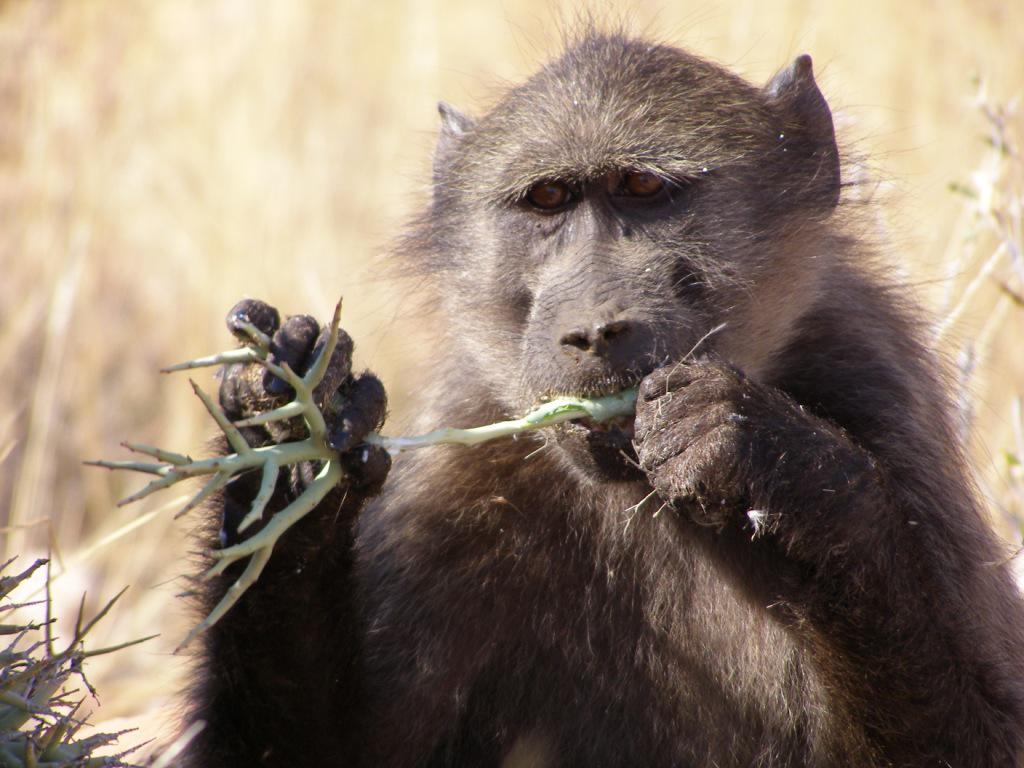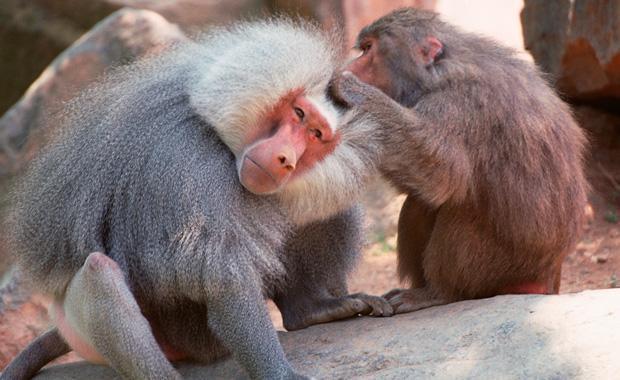The first image is the image on the left, the second image is the image on the right. For the images displayed, is the sentence "There's at least one monkey eating an animal." factually correct? Answer yes or no. No. 